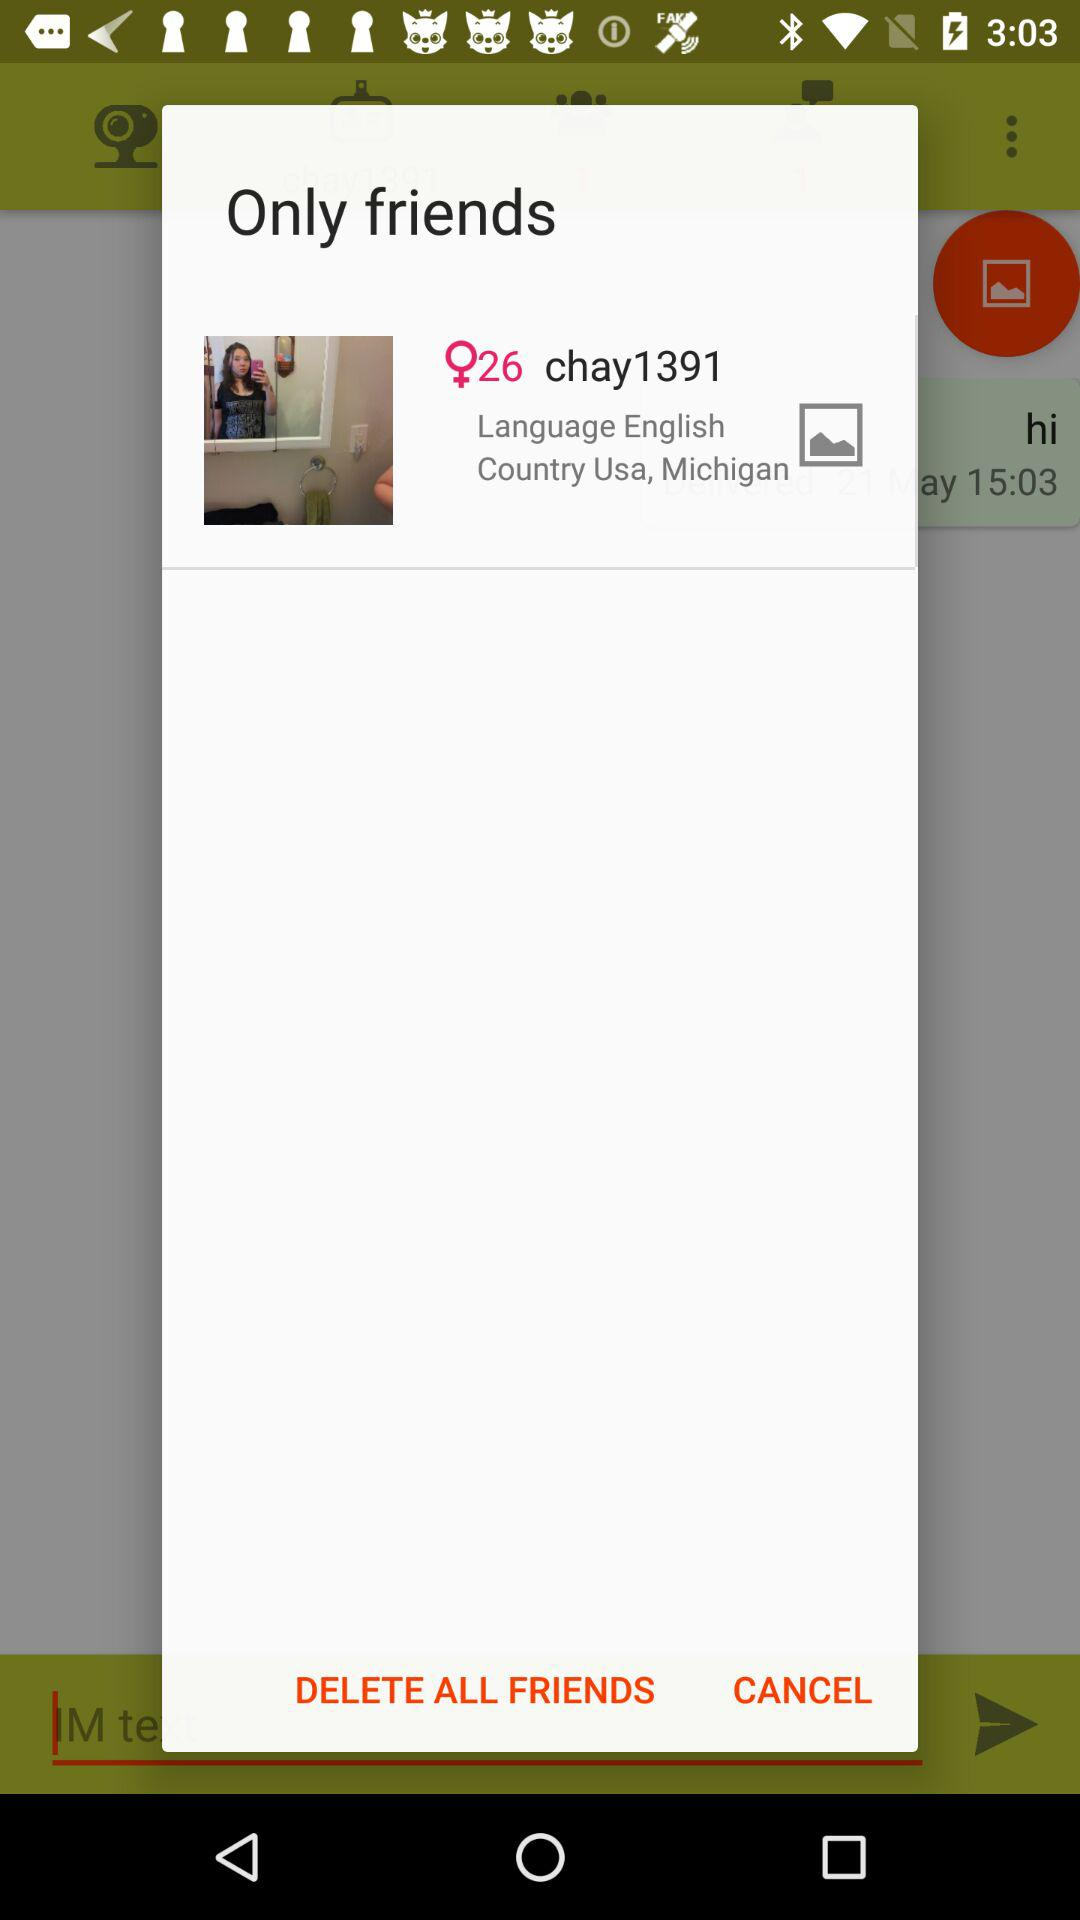What is the language and the country? The language is English and the country is the USA. 